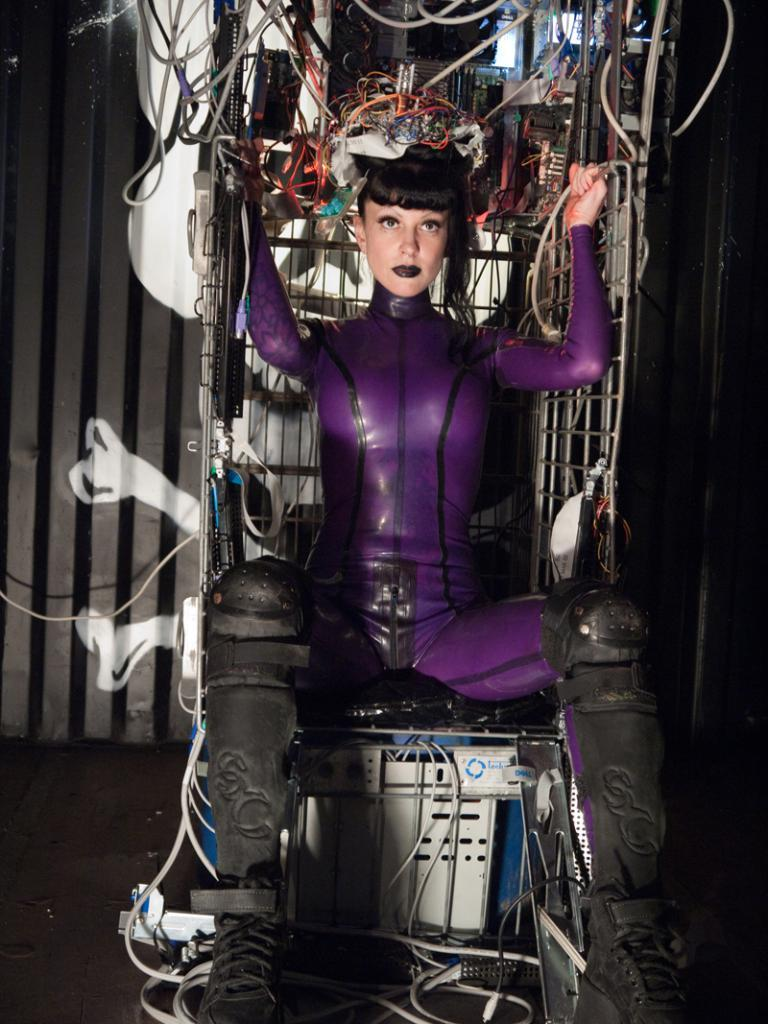Who is the main subject in the image? There is a woman in the image. What is the woman doing in the image? The woman is sitting on an electronic gadget. What is the woman holding in her hands? The woman is holding something with her hands. What can be seen on the woman's head? There are electronic objects on the woman's head. What type of toy can be seen in the woman's pail in the image? There is no pail or toy present in the image. What kind of music is being played in the background of the image? There is no music or indication of sound in the image. 